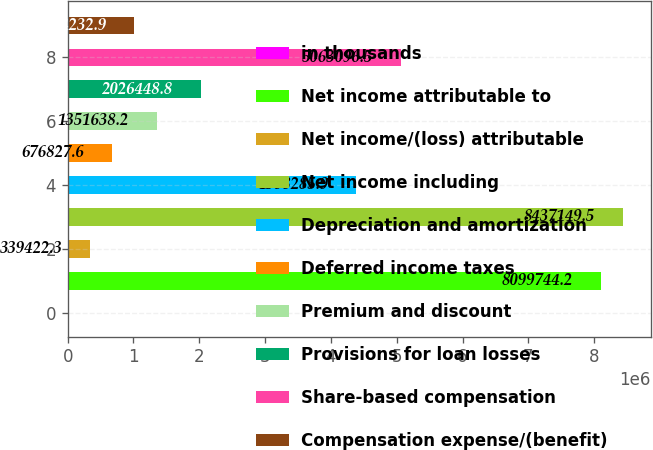Convert chart to OTSL. <chart><loc_0><loc_0><loc_500><loc_500><bar_chart><fcel>in thousands<fcel>Net income attributable to<fcel>Net income/(loss) attributable<fcel>Net income including<fcel>Depreciation and amortization<fcel>Deferred income taxes<fcel>Premium and discount<fcel>Provisions for loan losses<fcel>Share-based compensation<fcel>Compensation expense/(benefit)<nl><fcel>2017<fcel>8.09974e+06<fcel>339422<fcel>8.43715e+06<fcel>4.38829e+06<fcel>676828<fcel>1.35164e+06<fcel>2.02645e+06<fcel>5.0631e+06<fcel>1.01423e+06<nl></chart> 